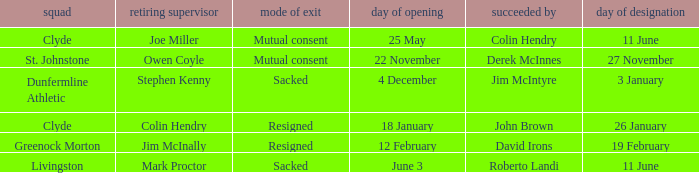Tell me the outgoing manager for 22 november date of vacancy Owen Coyle. 